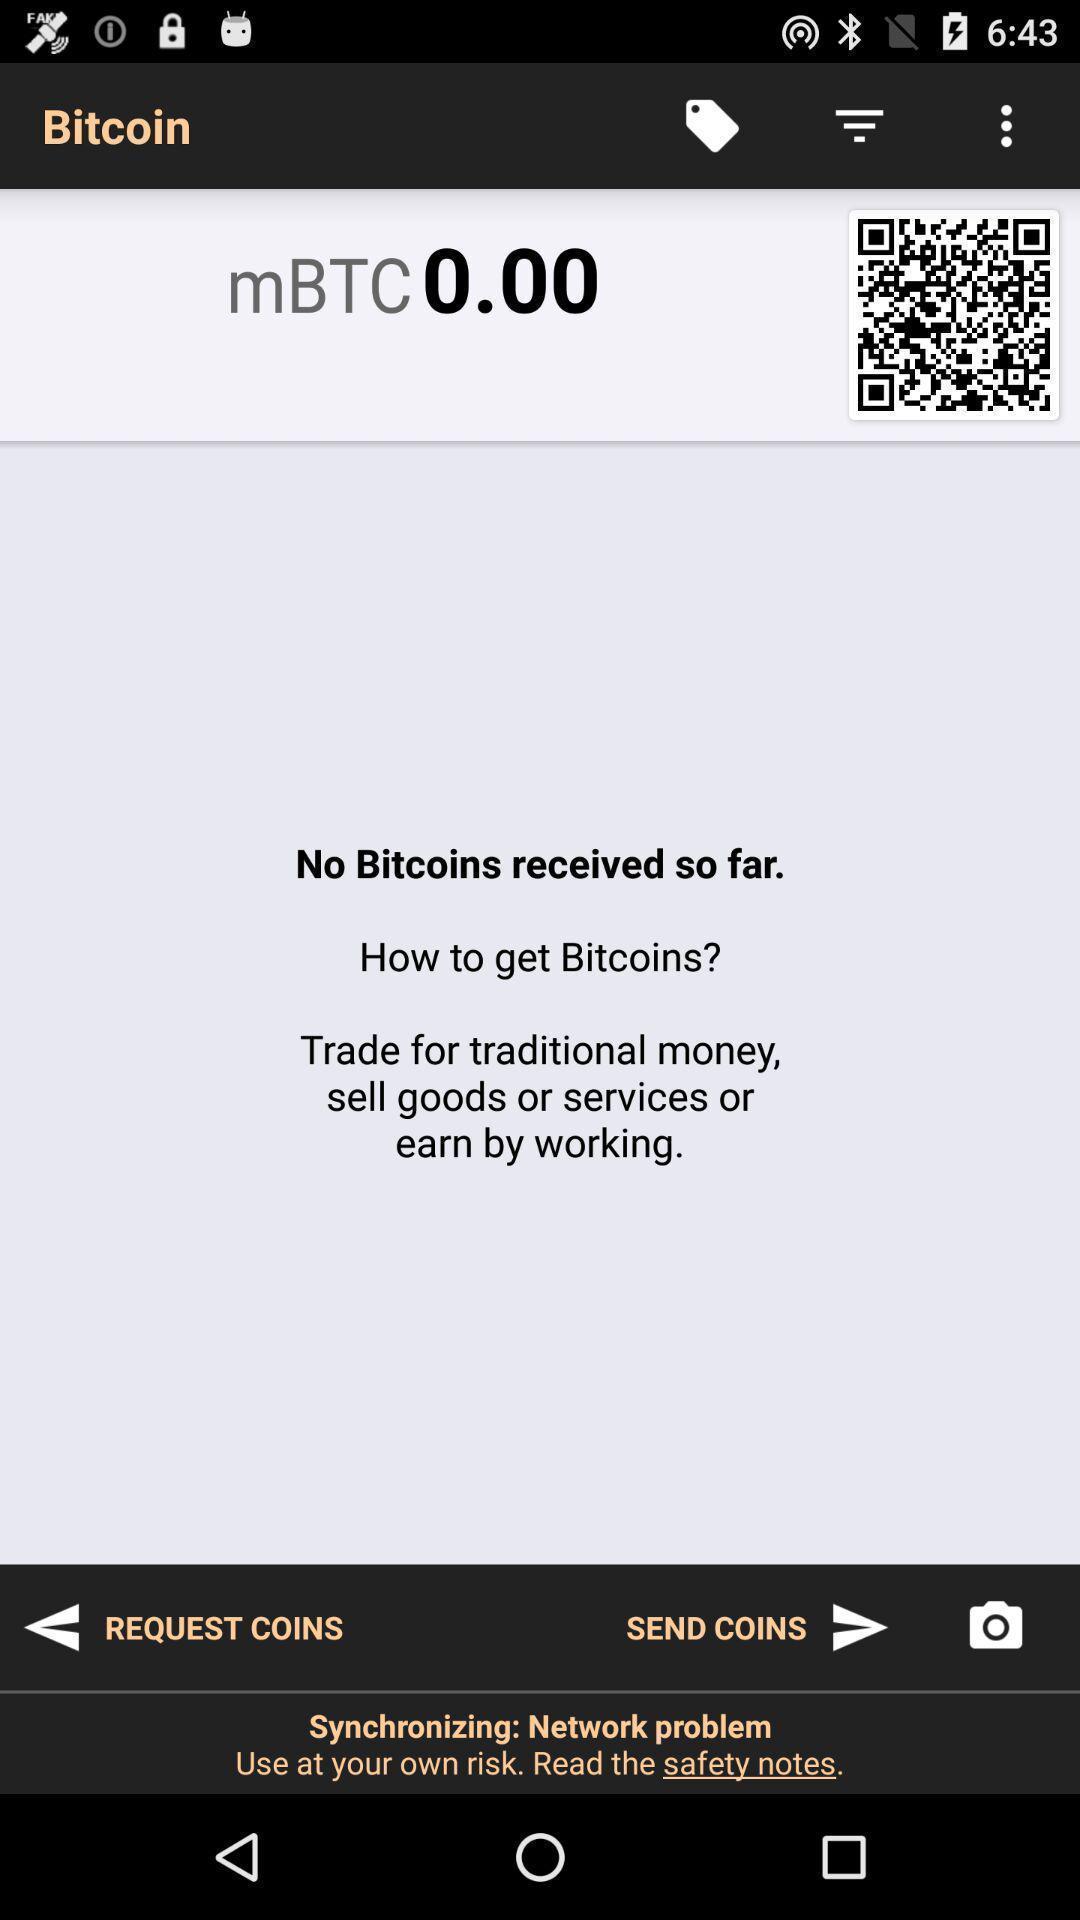Tell me about the visual elements in this screen capture. Page for digital transactions. 